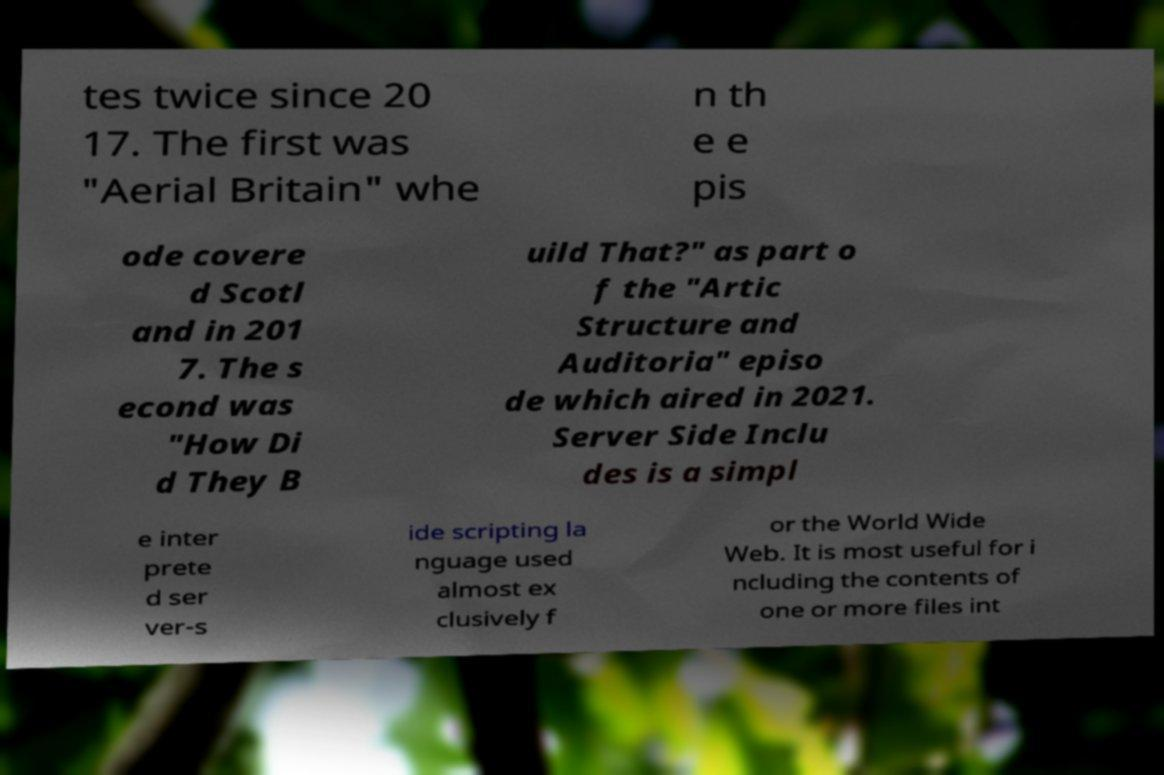Could you extract and type out the text from this image? tes twice since 20 17. The first was "Aerial Britain" whe n th e e pis ode covere d Scotl and in 201 7. The s econd was "How Di d They B uild That?" as part o f the "Artic Structure and Auditoria" episo de which aired in 2021. Server Side Inclu des is a simpl e inter prete d ser ver-s ide scripting la nguage used almost ex clusively f or the World Wide Web. It is most useful for i ncluding the contents of one or more files int 